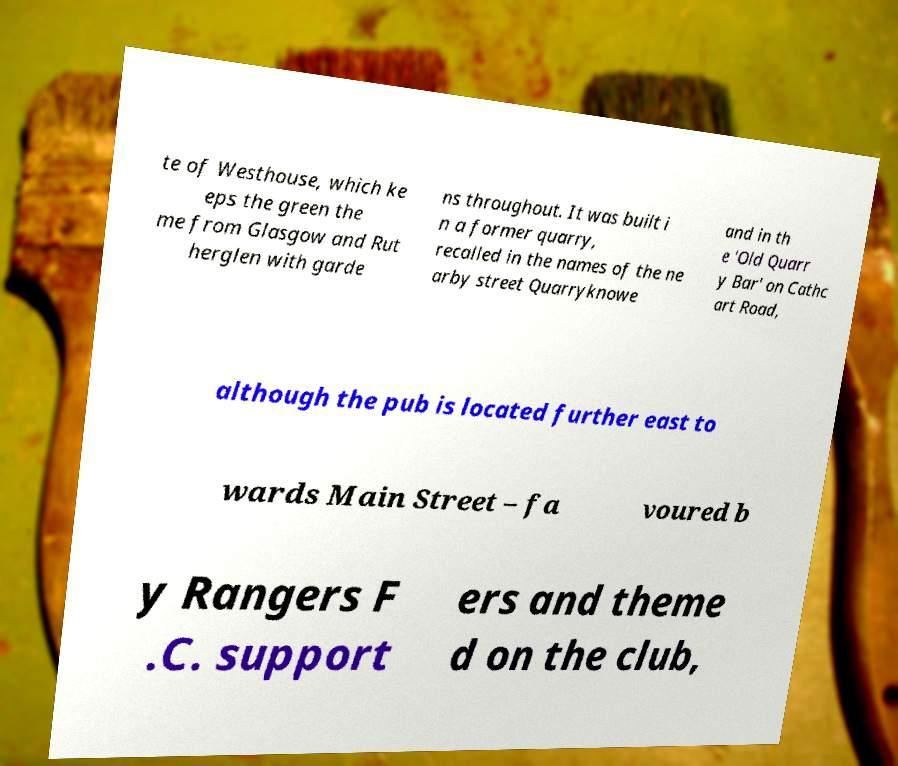For documentation purposes, I need the text within this image transcribed. Could you provide that? te of Westhouse, which ke eps the green the me from Glasgow and Rut herglen with garde ns throughout. It was built i n a former quarry, recalled in the names of the ne arby street Quarryknowe and in th e 'Old Quarr y Bar' on Cathc art Road, although the pub is located further east to wards Main Street – fa voured b y Rangers F .C. support ers and theme d on the club, 